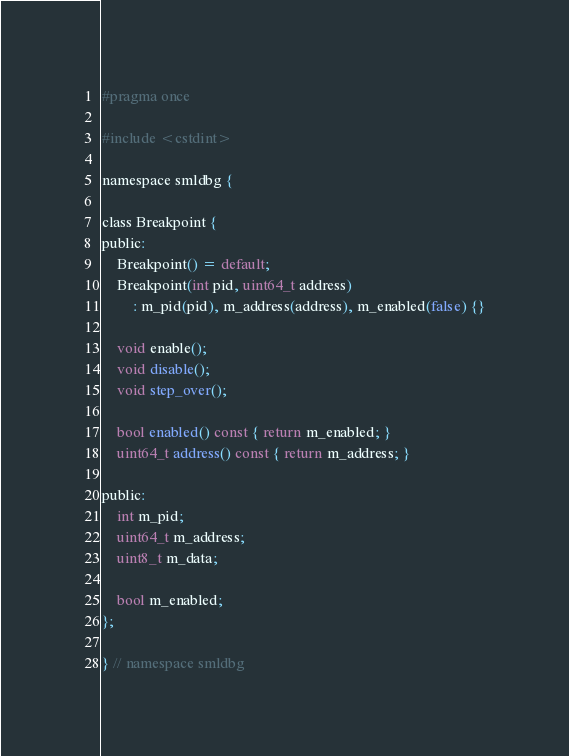<code> <loc_0><loc_0><loc_500><loc_500><_C_>#pragma once

#include <cstdint>

namespace smldbg {

class Breakpoint {
public:
    Breakpoint() = default;
    Breakpoint(int pid, uint64_t address)
        : m_pid(pid), m_address(address), m_enabled(false) {}

    void enable();
    void disable();
    void step_over();

    bool enabled() const { return m_enabled; }
    uint64_t address() const { return m_address; }

public:
    int m_pid;
    uint64_t m_address;
    uint8_t m_data;

    bool m_enabled;
};

} // namespace smldbg
</code> 